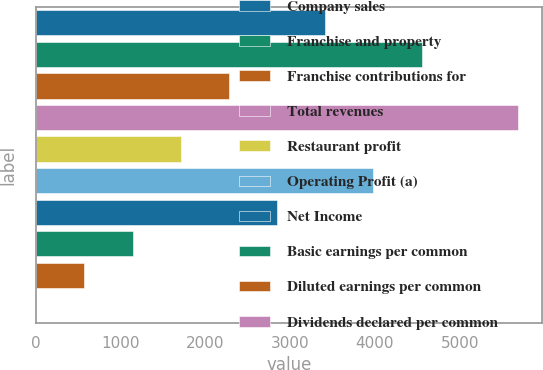<chart> <loc_0><loc_0><loc_500><loc_500><bar_chart><fcel>Company sales<fcel>Franchise and property<fcel>Franchise contributions for<fcel>Total revenues<fcel>Restaurant profit<fcel>Operating Profit (a)<fcel>Net Income<fcel>Basic earnings per common<fcel>Diluted earnings per common<fcel>Dividends declared per common<nl><fcel>3413.4<fcel>4550.72<fcel>2276.08<fcel>5688<fcel>1707.42<fcel>3982.06<fcel>2844.74<fcel>1138.76<fcel>570.1<fcel>1.44<nl></chart> 